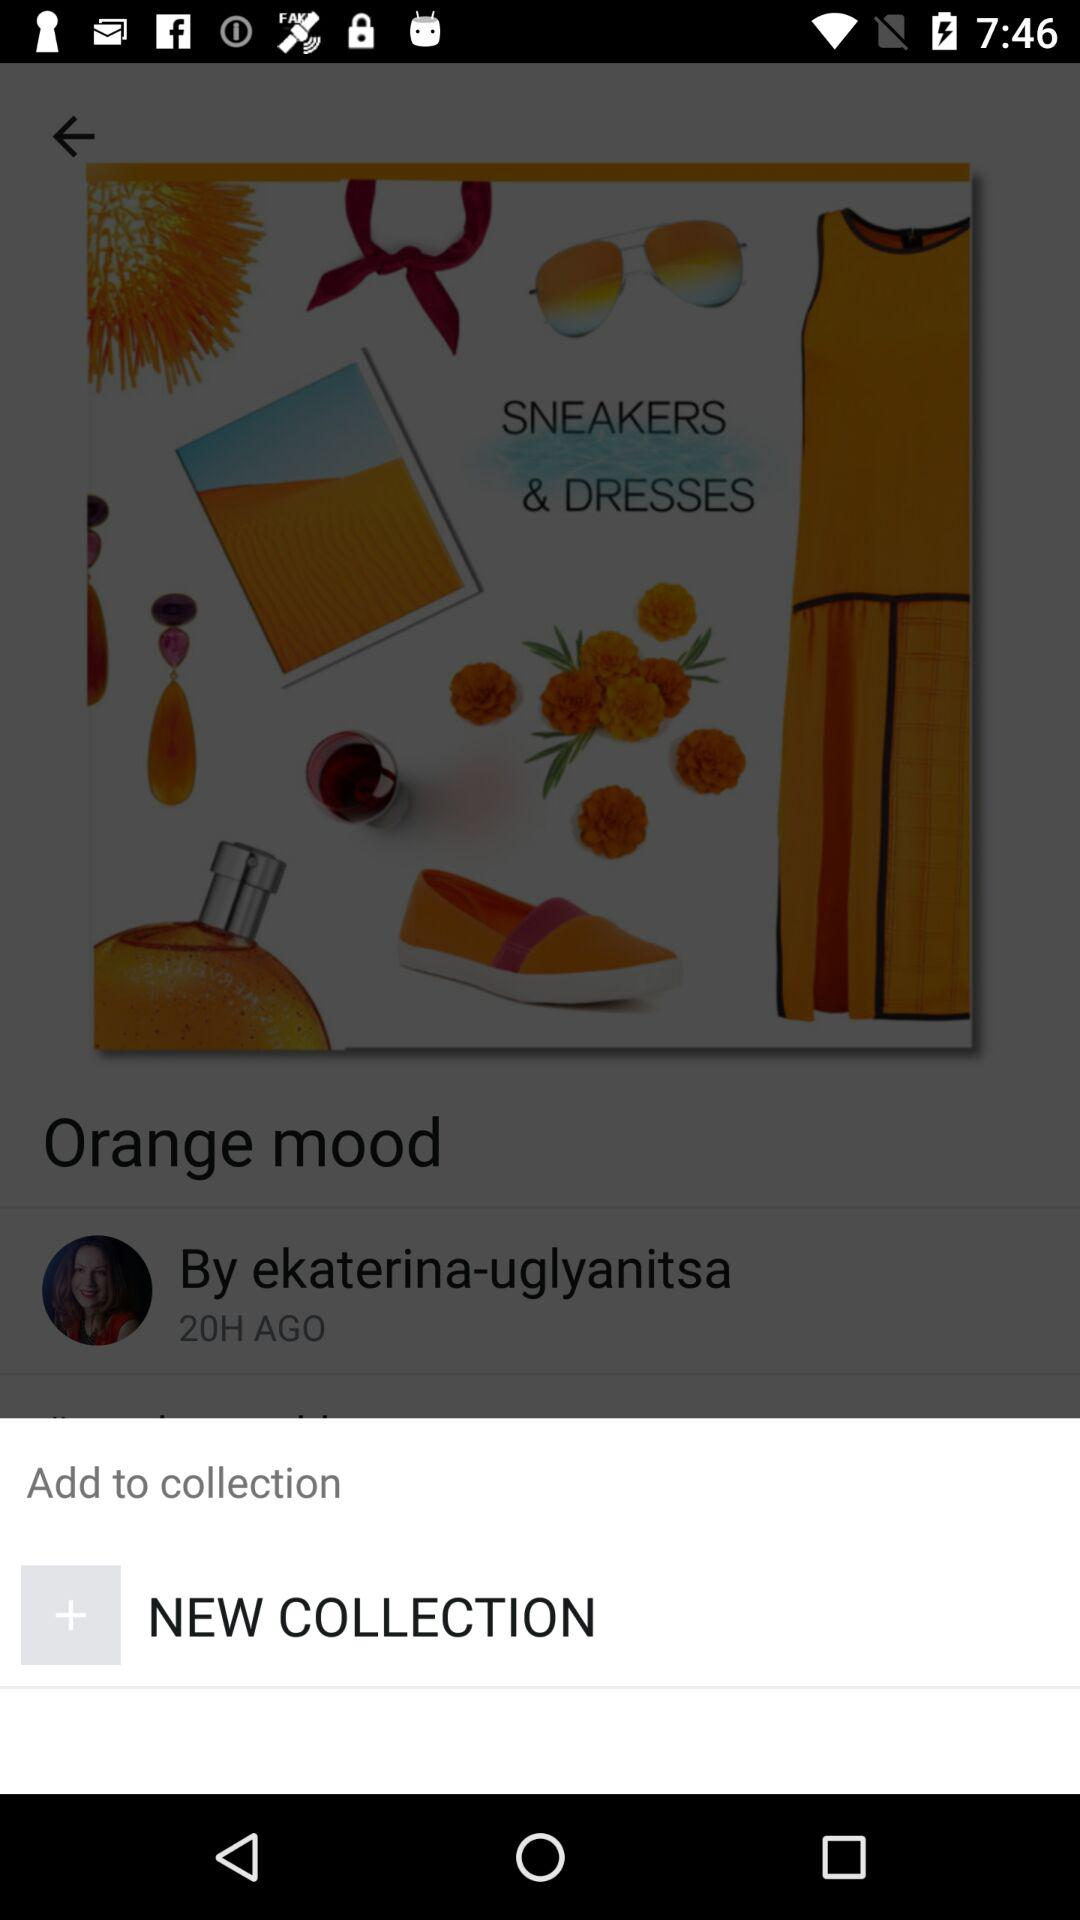What is the name of the author? The name of the author is Ekaterina-Uglyanitsa. 